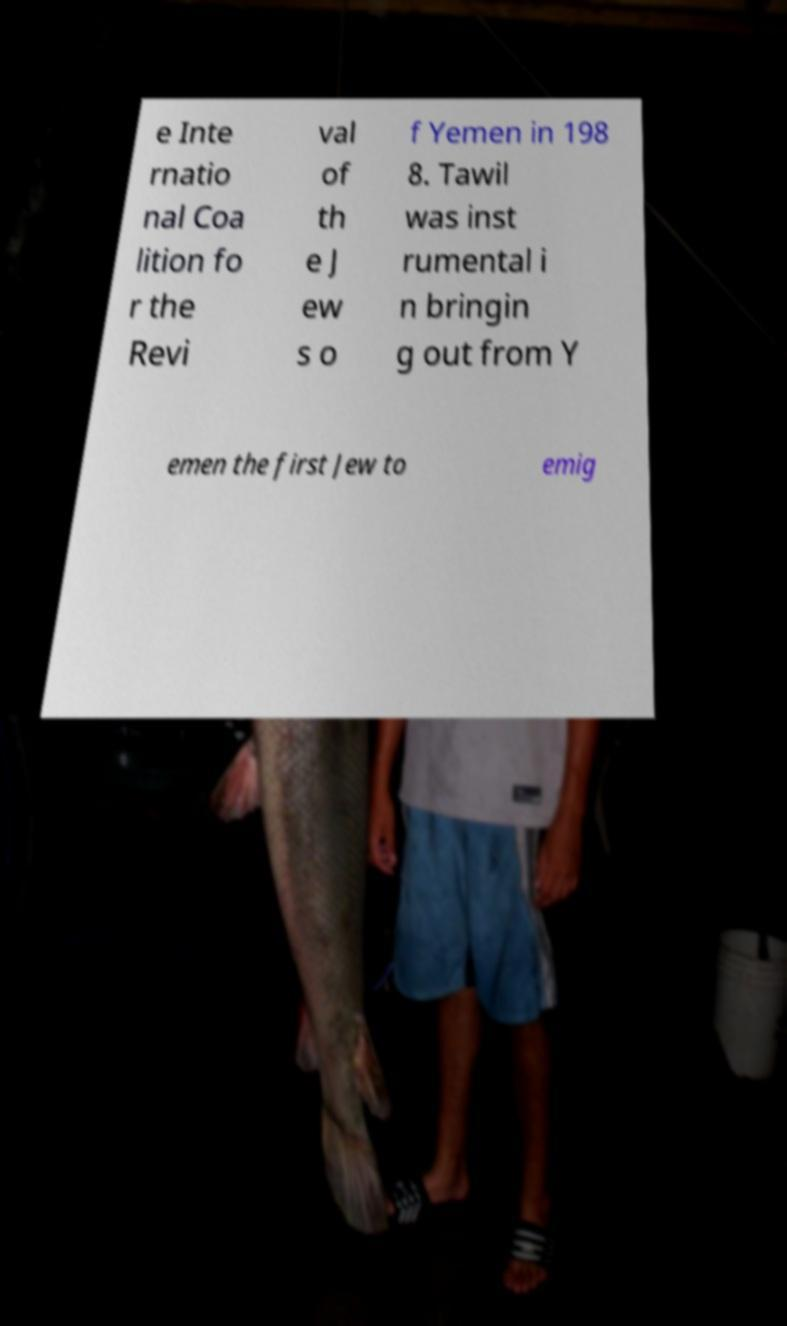For documentation purposes, I need the text within this image transcribed. Could you provide that? e Inte rnatio nal Coa lition fo r the Revi val of th e J ew s o f Yemen in 198 8. Tawil was inst rumental i n bringin g out from Y emen the first Jew to emig 